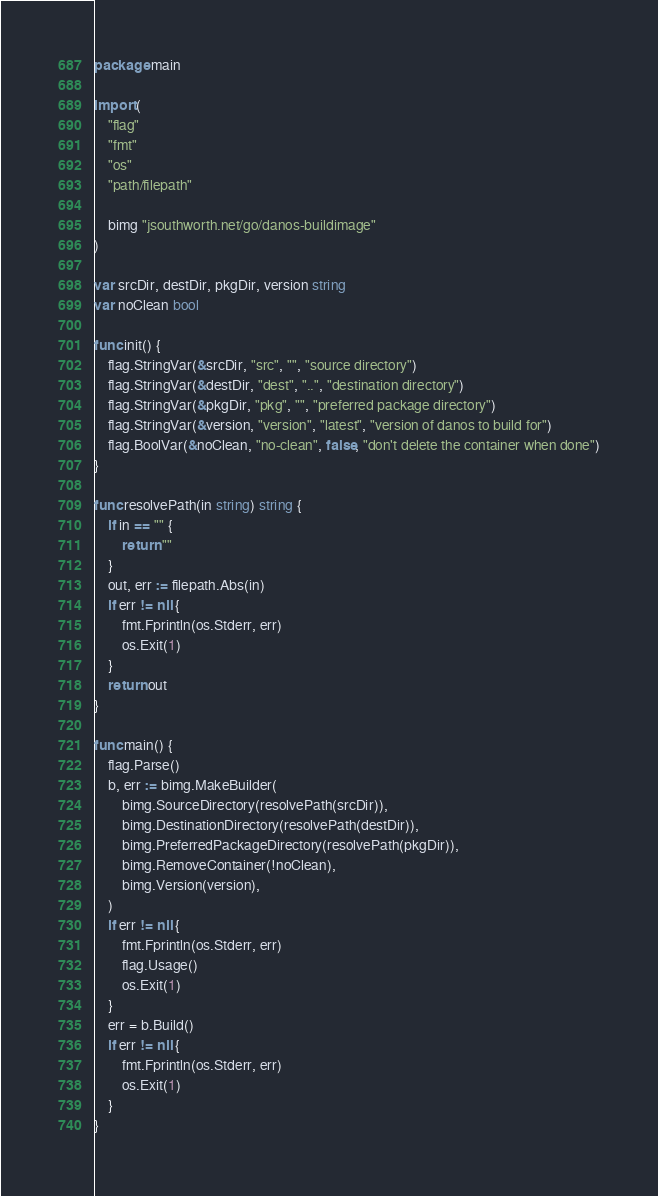<code> <loc_0><loc_0><loc_500><loc_500><_Go_>package main

import (
	"flag"
	"fmt"
	"os"
	"path/filepath"

	bimg "jsouthworth.net/go/danos-buildimage"
)

var srcDir, destDir, pkgDir, version string
var noClean bool

func init() {
	flag.StringVar(&srcDir, "src", "", "source directory")
	flag.StringVar(&destDir, "dest", "..", "destination directory")
	flag.StringVar(&pkgDir, "pkg", "", "preferred package directory")
	flag.StringVar(&version, "version", "latest", "version of danos to build for")
	flag.BoolVar(&noClean, "no-clean", false, "don't delete the container when done")
}

func resolvePath(in string) string {
	if in == "" {
		return ""
	}
	out, err := filepath.Abs(in)
	if err != nil {
		fmt.Fprintln(os.Stderr, err)
		os.Exit(1)
	}
	return out
}

func main() {
	flag.Parse()
	b, err := bimg.MakeBuilder(
		bimg.SourceDirectory(resolvePath(srcDir)),
		bimg.DestinationDirectory(resolvePath(destDir)),
		bimg.PreferredPackageDirectory(resolvePath(pkgDir)),
		bimg.RemoveContainer(!noClean),
		bimg.Version(version),
	)
	if err != nil {
		fmt.Fprintln(os.Stderr, err)
		flag.Usage()
		os.Exit(1)
	}
	err = b.Build()
	if err != nil {
		fmt.Fprintln(os.Stderr, err)
		os.Exit(1)
	}
}
</code> 